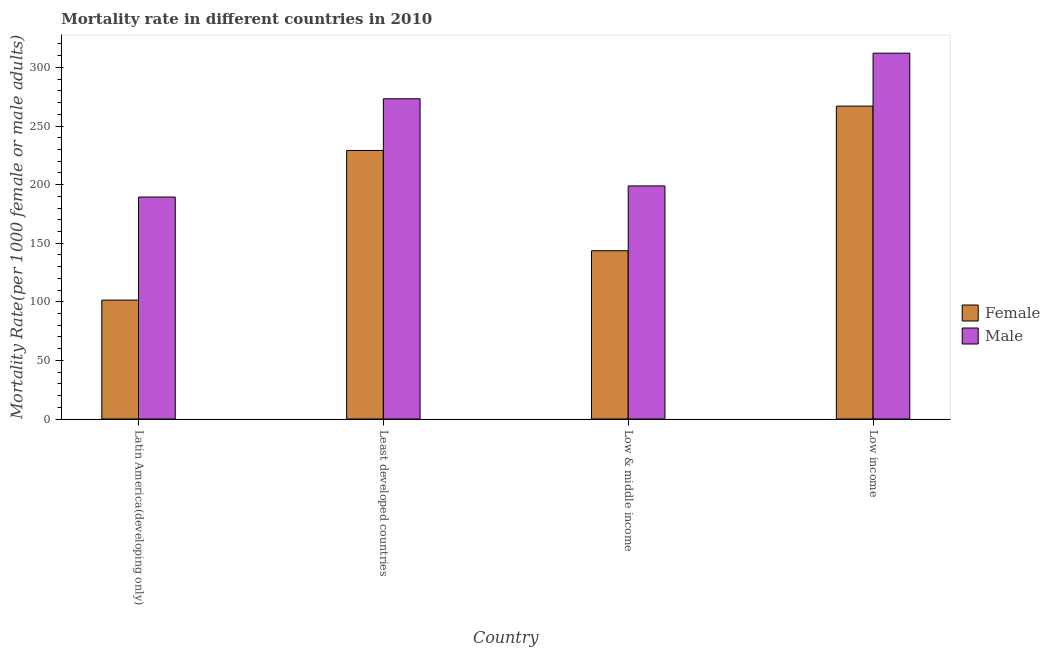How many different coloured bars are there?
Provide a succinct answer. 2. How many groups of bars are there?
Keep it short and to the point. 4. Are the number of bars per tick equal to the number of legend labels?
Your response must be concise. Yes. What is the female mortality rate in Low & middle income?
Offer a terse response. 143.57. Across all countries, what is the maximum female mortality rate?
Your answer should be compact. 266.96. Across all countries, what is the minimum male mortality rate?
Keep it short and to the point. 189.39. In which country was the female mortality rate minimum?
Provide a short and direct response. Latin America(developing only). What is the total male mortality rate in the graph?
Provide a succinct answer. 973.63. What is the difference between the male mortality rate in Latin America(developing only) and that in Least developed countries?
Make the answer very short. -83.85. What is the difference between the male mortality rate in Latin America(developing only) and the female mortality rate in Low & middle income?
Your answer should be very brief. 45.82. What is the average male mortality rate per country?
Your response must be concise. 243.41. What is the difference between the female mortality rate and male mortality rate in Low income?
Your answer should be compact. -45.18. What is the ratio of the female mortality rate in Latin America(developing only) to that in Low income?
Keep it short and to the point. 0.38. Is the female mortality rate in Least developed countries less than that in Low income?
Offer a terse response. Yes. Is the difference between the female mortality rate in Least developed countries and Low income greater than the difference between the male mortality rate in Least developed countries and Low income?
Offer a terse response. Yes. What is the difference between the highest and the second highest male mortality rate?
Your answer should be very brief. 38.9. What is the difference between the highest and the lowest female mortality rate?
Your answer should be compact. 165.5. Is the sum of the female mortality rate in Latin America(developing only) and Low income greater than the maximum male mortality rate across all countries?
Offer a terse response. Yes. What does the 1st bar from the left in Least developed countries represents?
Offer a terse response. Female. How many bars are there?
Provide a succinct answer. 8. How many legend labels are there?
Your response must be concise. 2. How are the legend labels stacked?
Give a very brief answer. Vertical. What is the title of the graph?
Offer a very short reply. Mortality rate in different countries in 2010. Does "Death rate" appear as one of the legend labels in the graph?
Provide a succinct answer. No. What is the label or title of the Y-axis?
Your answer should be very brief. Mortality Rate(per 1000 female or male adults). What is the Mortality Rate(per 1000 female or male adults) in Female in Latin America(developing only)?
Give a very brief answer. 101.46. What is the Mortality Rate(per 1000 female or male adults) in Male in Latin America(developing only)?
Make the answer very short. 189.39. What is the Mortality Rate(per 1000 female or male adults) of Female in Least developed countries?
Ensure brevity in your answer.  229.14. What is the Mortality Rate(per 1000 female or male adults) of Male in Least developed countries?
Provide a succinct answer. 273.24. What is the Mortality Rate(per 1000 female or male adults) in Female in Low & middle income?
Keep it short and to the point. 143.57. What is the Mortality Rate(per 1000 female or male adults) of Male in Low & middle income?
Offer a very short reply. 198.87. What is the Mortality Rate(per 1000 female or male adults) of Female in Low income?
Your answer should be very brief. 266.96. What is the Mortality Rate(per 1000 female or male adults) in Male in Low income?
Offer a terse response. 312.14. Across all countries, what is the maximum Mortality Rate(per 1000 female or male adults) of Female?
Provide a short and direct response. 266.96. Across all countries, what is the maximum Mortality Rate(per 1000 female or male adults) of Male?
Your answer should be very brief. 312.14. Across all countries, what is the minimum Mortality Rate(per 1000 female or male adults) of Female?
Ensure brevity in your answer.  101.46. Across all countries, what is the minimum Mortality Rate(per 1000 female or male adults) of Male?
Provide a succinct answer. 189.39. What is the total Mortality Rate(per 1000 female or male adults) of Female in the graph?
Offer a very short reply. 741.13. What is the total Mortality Rate(per 1000 female or male adults) in Male in the graph?
Ensure brevity in your answer.  973.63. What is the difference between the Mortality Rate(per 1000 female or male adults) of Female in Latin America(developing only) and that in Least developed countries?
Offer a terse response. -127.68. What is the difference between the Mortality Rate(per 1000 female or male adults) in Male in Latin America(developing only) and that in Least developed countries?
Keep it short and to the point. -83.85. What is the difference between the Mortality Rate(per 1000 female or male adults) of Female in Latin America(developing only) and that in Low & middle income?
Your answer should be very brief. -42.11. What is the difference between the Mortality Rate(per 1000 female or male adults) of Male in Latin America(developing only) and that in Low & middle income?
Make the answer very short. -9.48. What is the difference between the Mortality Rate(per 1000 female or male adults) in Female in Latin America(developing only) and that in Low income?
Provide a succinct answer. -165.5. What is the difference between the Mortality Rate(per 1000 female or male adults) of Male in Latin America(developing only) and that in Low income?
Give a very brief answer. -122.76. What is the difference between the Mortality Rate(per 1000 female or male adults) of Female in Least developed countries and that in Low & middle income?
Offer a very short reply. 85.57. What is the difference between the Mortality Rate(per 1000 female or male adults) of Male in Least developed countries and that in Low & middle income?
Offer a very short reply. 74.37. What is the difference between the Mortality Rate(per 1000 female or male adults) of Female in Least developed countries and that in Low income?
Keep it short and to the point. -37.82. What is the difference between the Mortality Rate(per 1000 female or male adults) in Male in Least developed countries and that in Low income?
Provide a succinct answer. -38.9. What is the difference between the Mortality Rate(per 1000 female or male adults) in Female in Low & middle income and that in Low income?
Make the answer very short. -123.39. What is the difference between the Mortality Rate(per 1000 female or male adults) of Male in Low & middle income and that in Low income?
Ensure brevity in your answer.  -113.27. What is the difference between the Mortality Rate(per 1000 female or male adults) in Female in Latin America(developing only) and the Mortality Rate(per 1000 female or male adults) in Male in Least developed countries?
Your answer should be compact. -171.78. What is the difference between the Mortality Rate(per 1000 female or male adults) in Female in Latin America(developing only) and the Mortality Rate(per 1000 female or male adults) in Male in Low & middle income?
Give a very brief answer. -97.41. What is the difference between the Mortality Rate(per 1000 female or male adults) in Female in Latin America(developing only) and the Mortality Rate(per 1000 female or male adults) in Male in Low income?
Ensure brevity in your answer.  -210.68. What is the difference between the Mortality Rate(per 1000 female or male adults) of Female in Least developed countries and the Mortality Rate(per 1000 female or male adults) of Male in Low & middle income?
Offer a very short reply. 30.27. What is the difference between the Mortality Rate(per 1000 female or male adults) of Female in Least developed countries and the Mortality Rate(per 1000 female or male adults) of Male in Low income?
Your answer should be compact. -83. What is the difference between the Mortality Rate(per 1000 female or male adults) in Female in Low & middle income and the Mortality Rate(per 1000 female or male adults) in Male in Low income?
Keep it short and to the point. -168.57. What is the average Mortality Rate(per 1000 female or male adults) in Female per country?
Give a very brief answer. 185.28. What is the average Mortality Rate(per 1000 female or male adults) in Male per country?
Give a very brief answer. 243.41. What is the difference between the Mortality Rate(per 1000 female or male adults) of Female and Mortality Rate(per 1000 female or male adults) of Male in Latin America(developing only)?
Keep it short and to the point. -87.92. What is the difference between the Mortality Rate(per 1000 female or male adults) in Female and Mortality Rate(per 1000 female or male adults) in Male in Least developed countries?
Give a very brief answer. -44.1. What is the difference between the Mortality Rate(per 1000 female or male adults) in Female and Mortality Rate(per 1000 female or male adults) in Male in Low & middle income?
Your response must be concise. -55.3. What is the difference between the Mortality Rate(per 1000 female or male adults) of Female and Mortality Rate(per 1000 female or male adults) of Male in Low income?
Your answer should be very brief. -45.18. What is the ratio of the Mortality Rate(per 1000 female or male adults) in Female in Latin America(developing only) to that in Least developed countries?
Offer a very short reply. 0.44. What is the ratio of the Mortality Rate(per 1000 female or male adults) in Male in Latin America(developing only) to that in Least developed countries?
Ensure brevity in your answer.  0.69. What is the ratio of the Mortality Rate(per 1000 female or male adults) of Female in Latin America(developing only) to that in Low & middle income?
Keep it short and to the point. 0.71. What is the ratio of the Mortality Rate(per 1000 female or male adults) of Male in Latin America(developing only) to that in Low & middle income?
Give a very brief answer. 0.95. What is the ratio of the Mortality Rate(per 1000 female or male adults) of Female in Latin America(developing only) to that in Low income?
Your response must be concise. 0.38. What is the ratio of the Mortality Rate(per 1000 female or male adults) of Male in Latin America(developing only) to that in Low income?
Offer a terse response. 0.61. What is the ratio of the Mortality Rate(per 1000 female or male adults) in Female in Least developed countries to that in Low & middle income?
Offer a terse response. 1.6. What is the ratio of the Mortality Rate(per 1000 female or male adults) in Male in Least developed countries to that in Low & middle income?
Your response must be concise. 1.37. What is the ratio of the Mortality Rate(per 1000 female or male adults) of Female in Least developed countries to that in Low income?
Offer a terse response. 0.86. What is the ratio of the Mortality Rate(per 1000 female or male adults) in Male in Least developed countries to that in Low income?
Ensure brevity in your answer.  0.88. What is the ratio of the Mortality Rate(per 1000 female or male adults) in Female in Low & middle income to that in Low income?
Your response must be concise. 0.54. What is the ratio of the Mortality Rate(per 1000 female or male adults) in Male in Low & middle income to that in Low income?
Your response must be concise. 0.64. What is the difference between the highest and the second highest Mortality Rate(per 1000 female or male adults) of Female?
Ensure brevity in your answer.  37.82. What is the difference between the highest and the second highest Mortality Rate(per 1000 female or male adults) in Male?
Your answer should be compact. 38.9. What is the difference between the highest and the lowest Mortality Rate(per 1000 female or male adults) in Female?
Offer a terse response. 165.5. What is the difference between the highest and the lowest Mortality Rate(per 1000 female or male adults) in Male?
Offer a terse response. 122.76. 